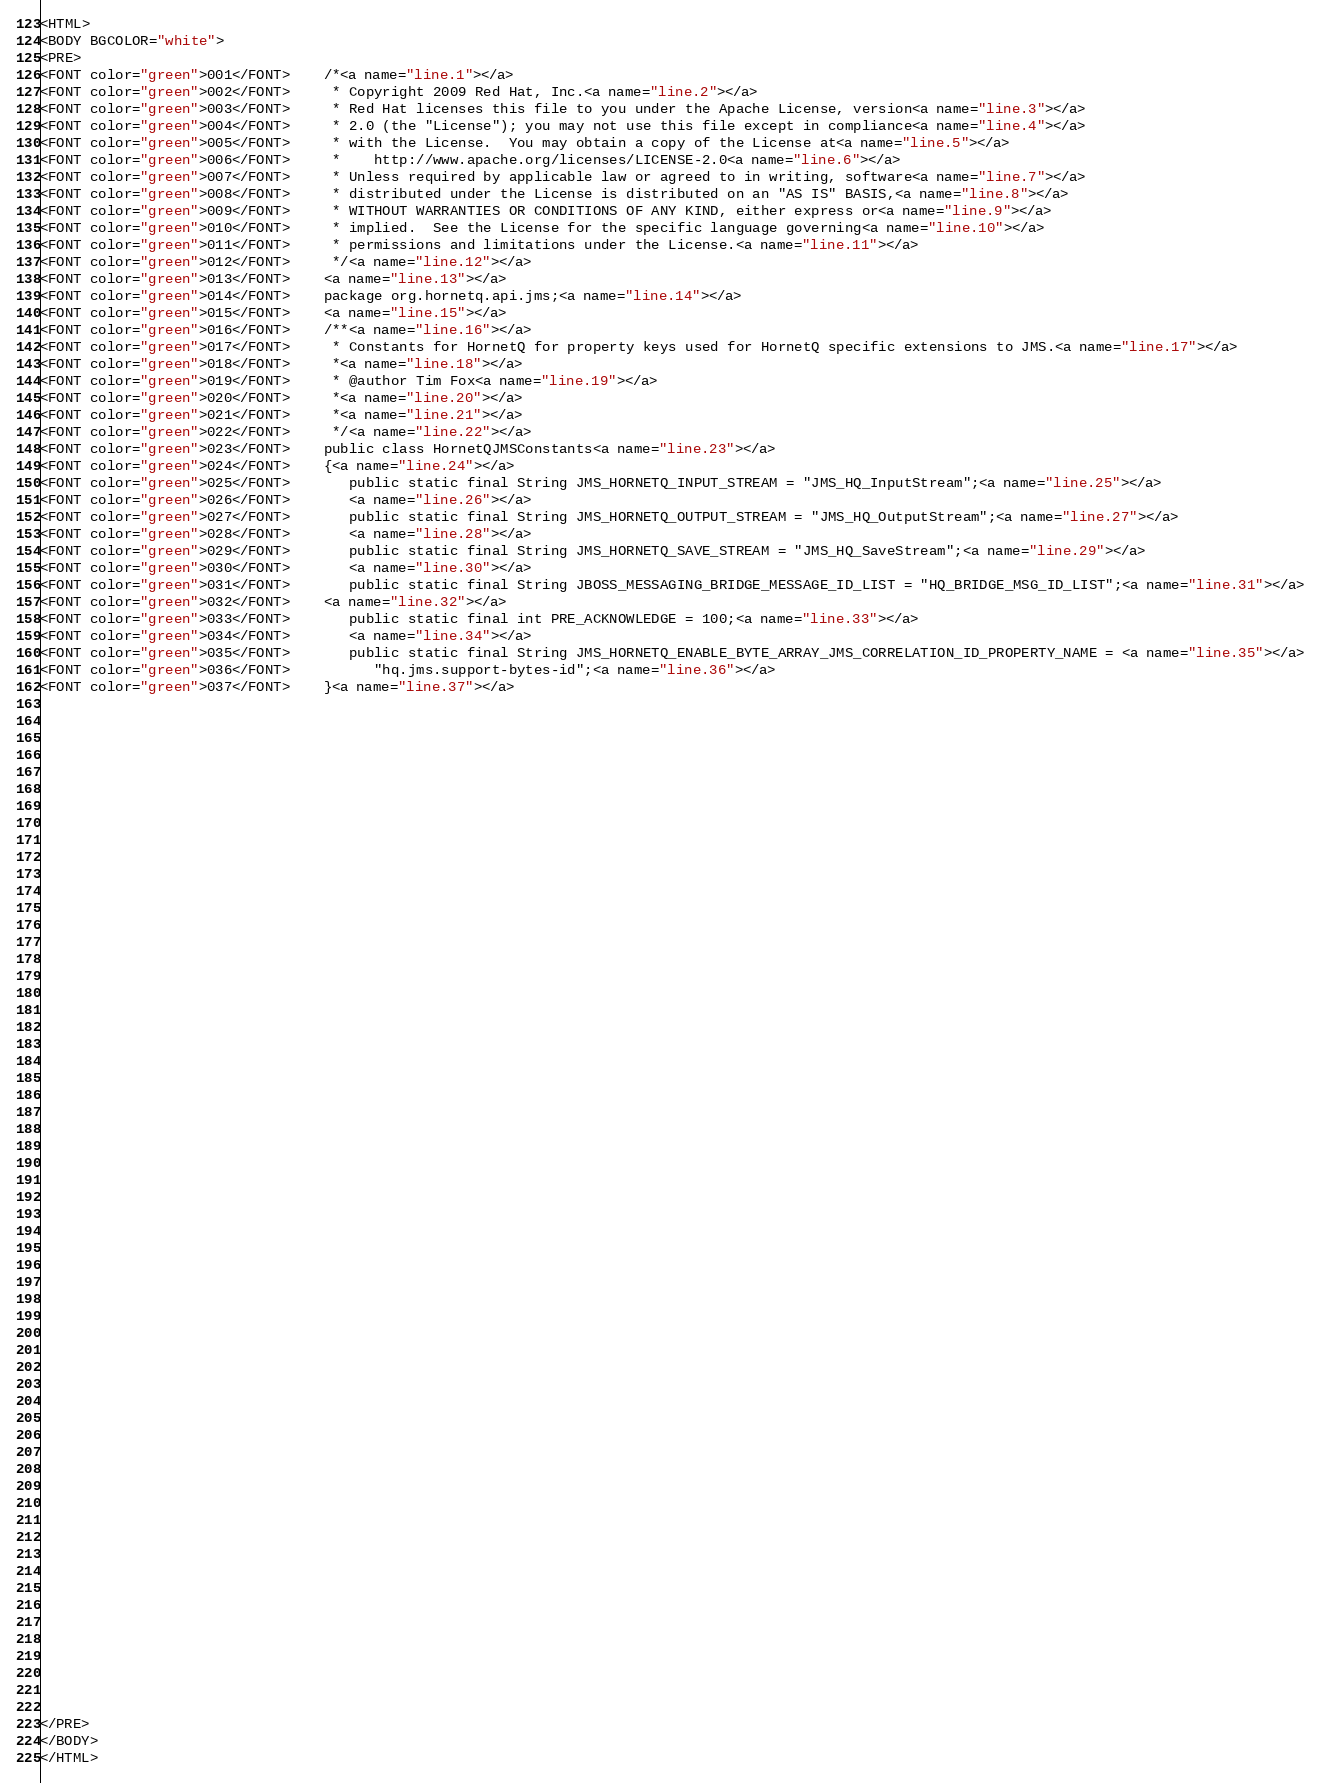Convert code to text. <code><loc_0><loc_0><loc_500><loc_500><_HTML_><HTML>
<BODY BGCOLOR="white">
<PRE>
<FONT color="green">001</FONT>    /*<a name="line.1"></a>
<FONT color="green">002</FONT>     * Copyright 2009 Red Hat, Inc.<a name="line.2"></a>
<FONT color="green">003</FONT>     * Red Hat licenses this file to you under the Apache License, version<a name="line.3"></a>
<FONT color="green">004</FONT>     * 2.0 (the "License"); you may not use this file except in compliance<a name="line.4"></a>
<FONT color="green">005</FONT>     * with the License.  You may obtain a copy of the License at<a name="line.5"></a>
<FONT color="green">006</FONT>     *    http://www.apache.org/licenses/LICENSE-2.0<a name="line.6"></a>
<FONT color="green">007</FONT>     * Unless required by applicable law or agreed to in writing, software<a name="line.7"></a>
<FONT color="green">008</FONT>     * distributed under the License is distributed on an "AS IS" BASIS,<a name="line.8"></a>
<FONT color="green">009</FONT>     * WITHOUT WARRANTIES OR CONDITIONS OF ANY KIND, either express or<a name="line.9"></a>
<FONT color="green">010</FONT>     * implied.  See the License for the specific language governing<a name="line.10"></a>
<FONT color="green">011</FONT>     * permissions and limitations under the License.<a name="line.11"></a>
<FONT color="green">012</FONT>     */<a name="line.12"></a>
<FONT color="green">013</FONT>    <a name="line.13"></a>
<FONT color="green">014</FONT>    package org.hornetq.api.jms;<a name="line.14"></a>
<FONT color="green">015</FONT>    <a name="line.15"></a>
<FONT color="green">016</FONT>    /**<a name="line.16"></a>
<FONT color="green">017</FONT>     * Constants for HornetQ for property keys used for HornetQ specific extensions to JMS.<a name="line.17"></a>
<FONT color="green">018</FONT>     *<a name="line.18"></a>
<FONT color="green">019</FONT>     * @author Tim Fox<a name="line.19"></a>
<FONT color="green">020</FONT>     *<a name="line.20"></a>
<FONT color="green">021</FONT>     *<a name="line.21"></a>
<FONT color="green">022</FONT>     */<a name="line.22"></a>
<FONT color="green">023</FONT>    public class HornetQJMSConstants<a name="line.23"></a>
<FONT color="green">024</FONT>    {<a name="line.24"></a>
<FONT color="green">025</FONT>       public static final String JMS_HORNETQ_INPUT_STREAM = "JMS_HQ_InputStream";<a name="line.25"></a>
<FONT color="green">026</FONT>       <a name="line.26"></a>
<FONT color="green">027</FONT>       public static final String JMS_HORNETQ_OUTPUT_STREAM = "JMS_HQ_OutputStream";<a name="line.27"></a>
<FONT color="green">028</FONT>       <a name="line.28"></a>
<FONT color="green">029</FONT>       public static final String JMS_HORNETQ_SAVE_STREAM = "JMS_HQ_SaveStream";<a name="line.29"></a>
<FONT color="green">030</FONT>       <a name="line.30"></a>
<FONT color="green">031</FONT>       public static final String JBOSS_MESSAGING_BRIDGE_MESSAGE_ID_LIST = "HQ_BRIDGE_MSG_ID_LIST";<a name="line.31"></a>
<FONT color="green">032</FONT>    <a name="line.32"></a>
<FONT color="green">033</FONT>       public static final int PRE_ACKNOWLEDGE = 100;<a name="line.33"></a>
<FONT color="green">034</FONT>       <a name="line.34"></a>
<FONT color="green">035</FONT>       public static final String JMS_HORNETQ_ENABLE_BYTE_ARRAY_JMS_CORRELATION_ID_PROPERTY_NAME = <a name="line.35"></a>
<FONT color="green">036</FONT>          "hq.jms.support-bytes-id";<a name="line.36"></a>
<FONT color="green">037</FONT>    }<a name="line.37"></a>




























































</PRE>
</BODY>
</HTML>
</code> 